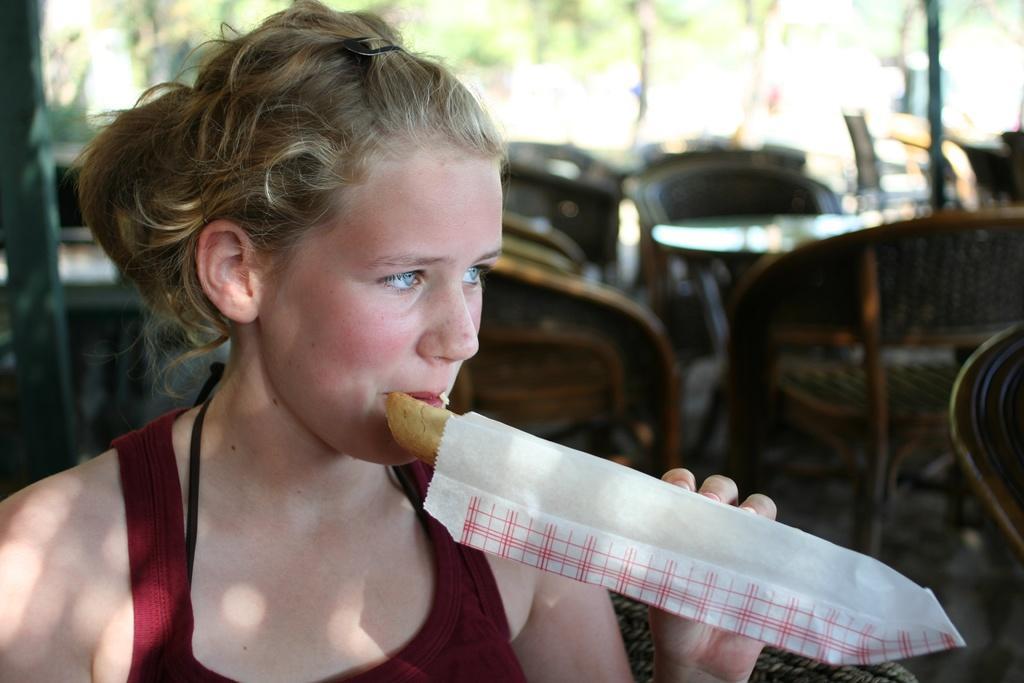Please provide a concise description of this image. There is a lady holding a food item in the foreground area of the image, there are chairs, tables, it seems like bamboos and greenery in the background. 